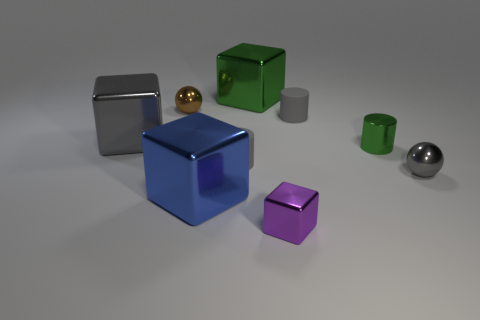How many brown metallic balls are in front of the metallic cylinder?
Give a very brief answer. 0. There is a blue metallic cube that is in front of the small gray metallic thing; is it the same size as the block right of the green cube?
Ensure brevity in your answer.  No. What number of other things are the same size as the gray ball?
Make the answer very short. 5. What material is the big object that is in front of the tiny shiny sphere in front of the gray metal thing left of the big green cube made of?
Your answer should be very brief. Metal. Is the size of the brown thing the same as the gray shiny thing that is on the right side of the blue cube?
Offer a terse response. Yes. There is a gray object that is behind the tiny gray metallic ball and in front of the big gray metal thing; what size is it?
Provide a short and direct response. Small. Is there a rubber sphere of the same color as the small shiny block?
Ensure brevity in your answer.  No. There is a small shiny sphere on the right side of the large thing that is behind the small brown metal sphere; what is its color?
Ensure brevity in your answer.  Gray. Are there fewer tiny shiny cubes that are on the right side of the brown object than gray shiny cubes that are in front of the tiny green cylinder?
Provide a short and direct response. No. Do the purple block and the gray metallic ball have the same size?
Keep it short and to the point. Yes. 